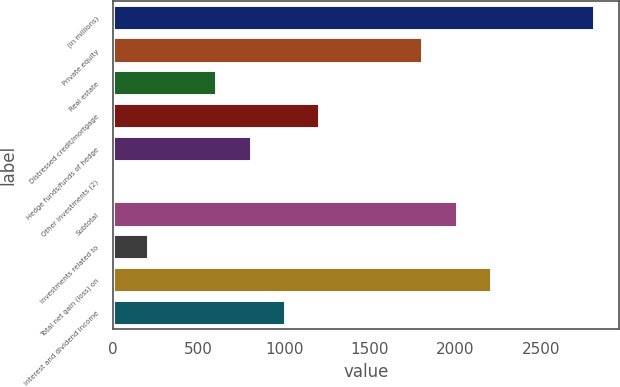Convert chart to OTSL. <chart><loc_0><loc_0><loc_500><loc_500><bar_chart><fcel>(in millions)<fcel>Private equity<fcel>Real estate<fcel>Distressed credit/mortgage<fcel>Hedge funds/funds of hedge<fcel>Other investments (2)<fcel>Subtotal<fcel>Investments related to<fcel>Total net gain (loss) on<fcel>Interest and dividend income<nl><fcel>2816.8<fcel>1813.3<fcel>609.1<fcel>1211.2<fcel>809.8<fcel>7<fcel>2014<fcel>207.7<fcel>2214.7<fcel>1010.5<nl></chart> 